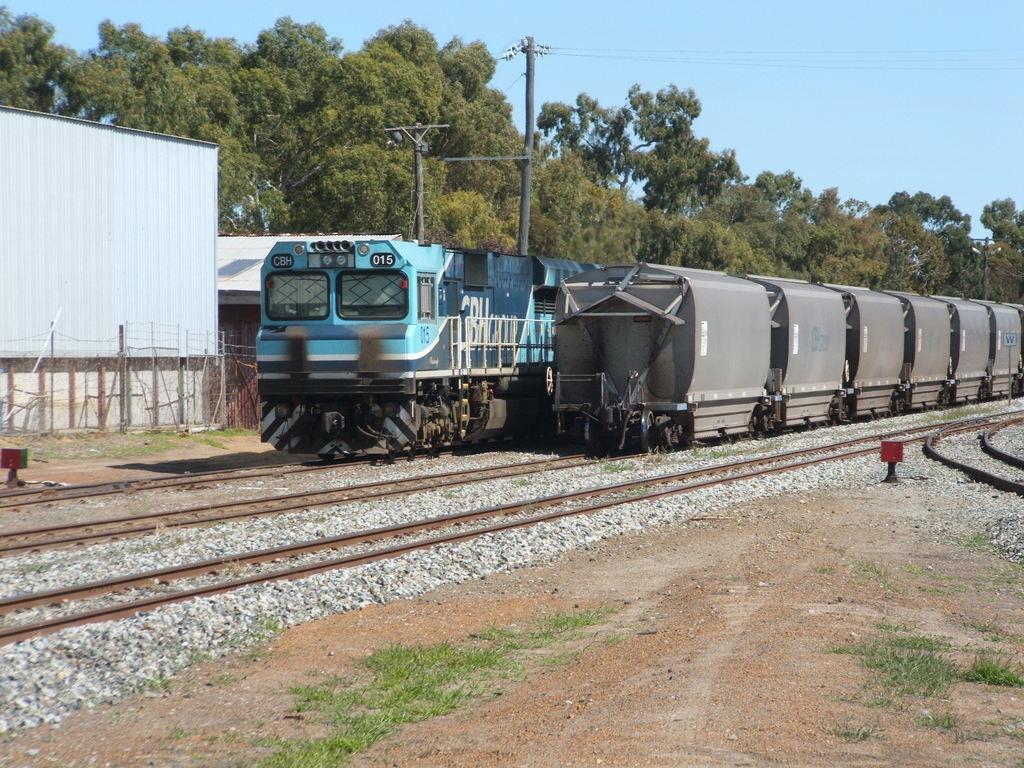Please provide a concise description of this image. In this picture I can see there are two trains passing here on two different tracks and there are buildings, trees and poles in the backdrop. The sky is clear. 